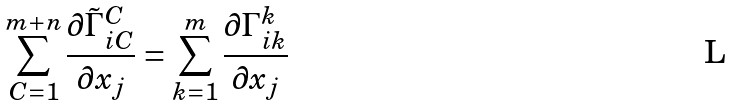Convert formula to latex. <formula><loc_0><loc_0><loc_500><loc_500>\sum ^ { m + n } _ { C = 1 } \frac { \partial \tilde { \Gamma } ^ { C } _ { i C } } { \partial x _ { j } } = \sum ^ { m } _ { k = 1 } \frac { \partial \Gamma ^ { k } _ { i k } } { \partial x _ { j } }</formula> 